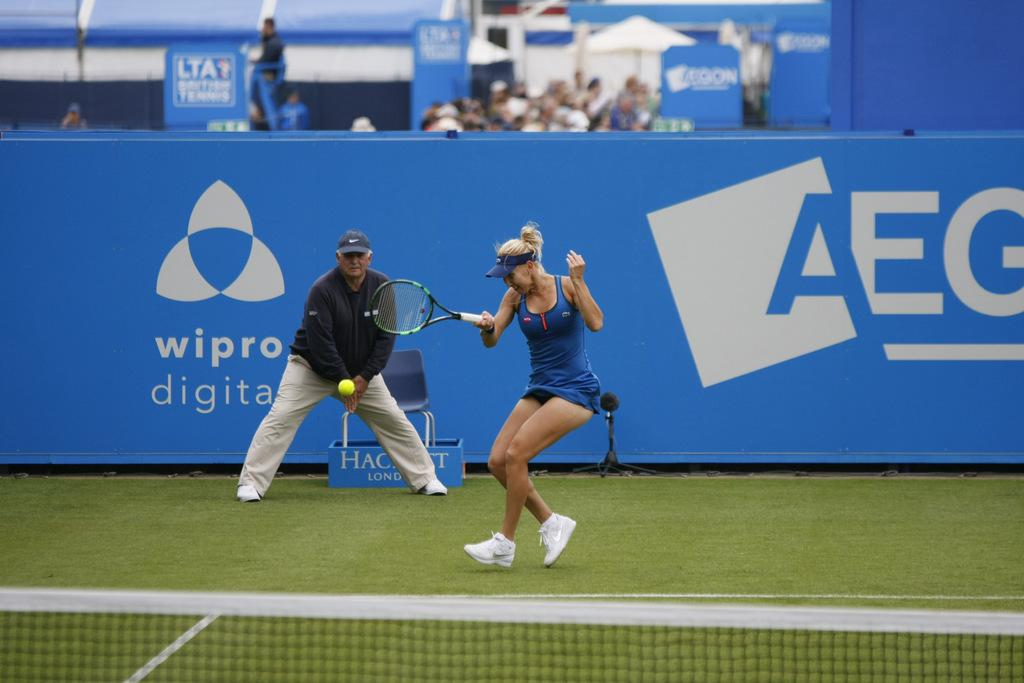What activity is the lady in the image engaged in? The lady in the image is playing tennis. Who is present in the image besides the lady playing tennis? There is a guy standing behind the lady, and there are people sitting behind the tennis court. What is the location of the scene in the image? The setting is a tennis court. What feature is common in most tennis courts? There is a net in the tennis court. Can you see any toy clover in the image? A: There is no toy clover present in the image. 